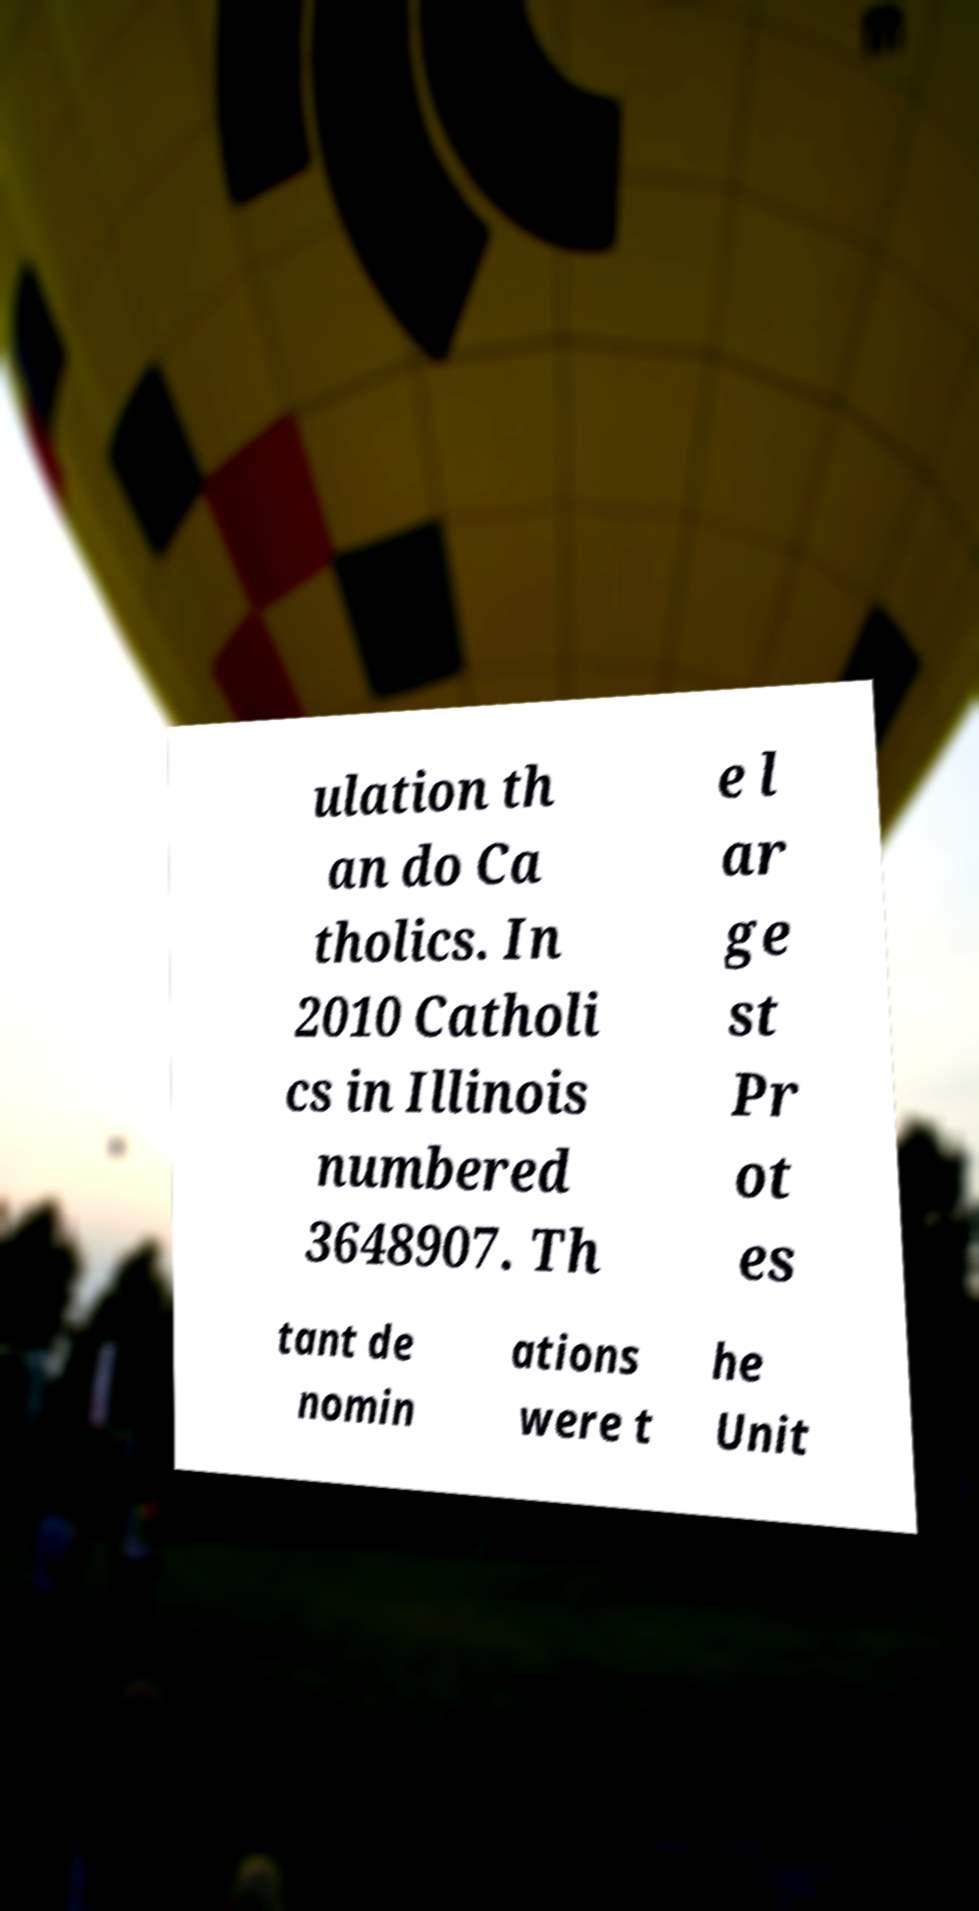I need the written content from this picture converted into text. Can you do that? ulation th an do Ca tholics. In 2010 Catholi cs in Illinois numbered 3648907. Th e l ar ge st Pr ot es tant de nomin ations were t he Unit 